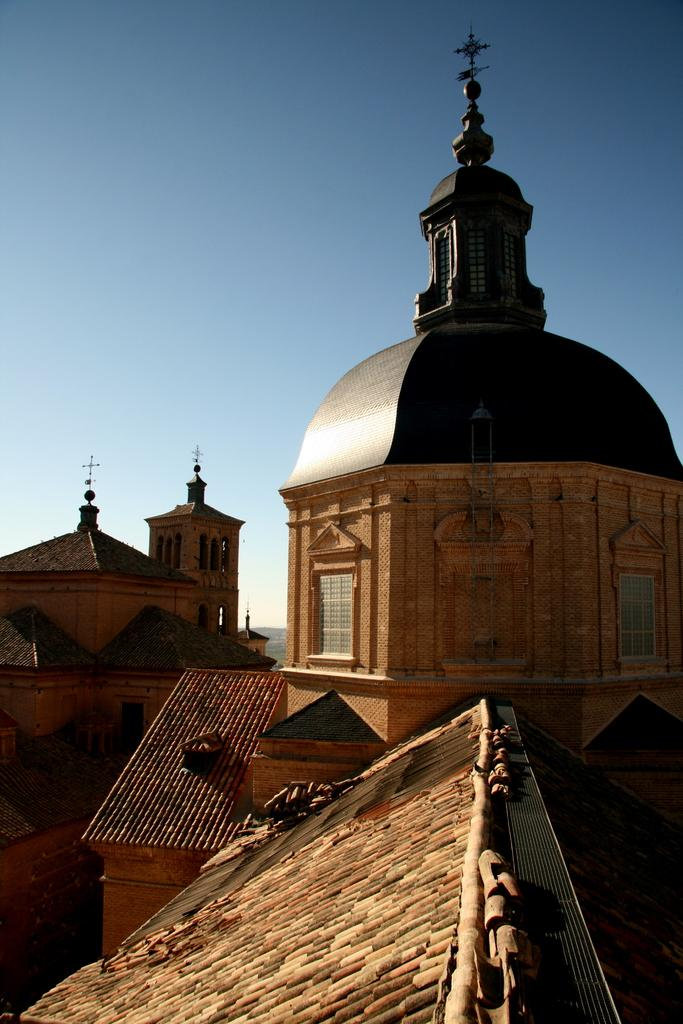What type of structures are present in the image? There are buildings in the image. What features can be observed on the buildings? The buildings have windows and arches. What religious symbol is present on top of the buildings? There are crosses on top of the buildings. What can be seen in the background of the image? The sky is visible in the background of the image. Can you find the twig that someone dropped in the image? There is no twig present in the image. What letter is written on the side of the building? There is no letter written on the side of the building in the image. 